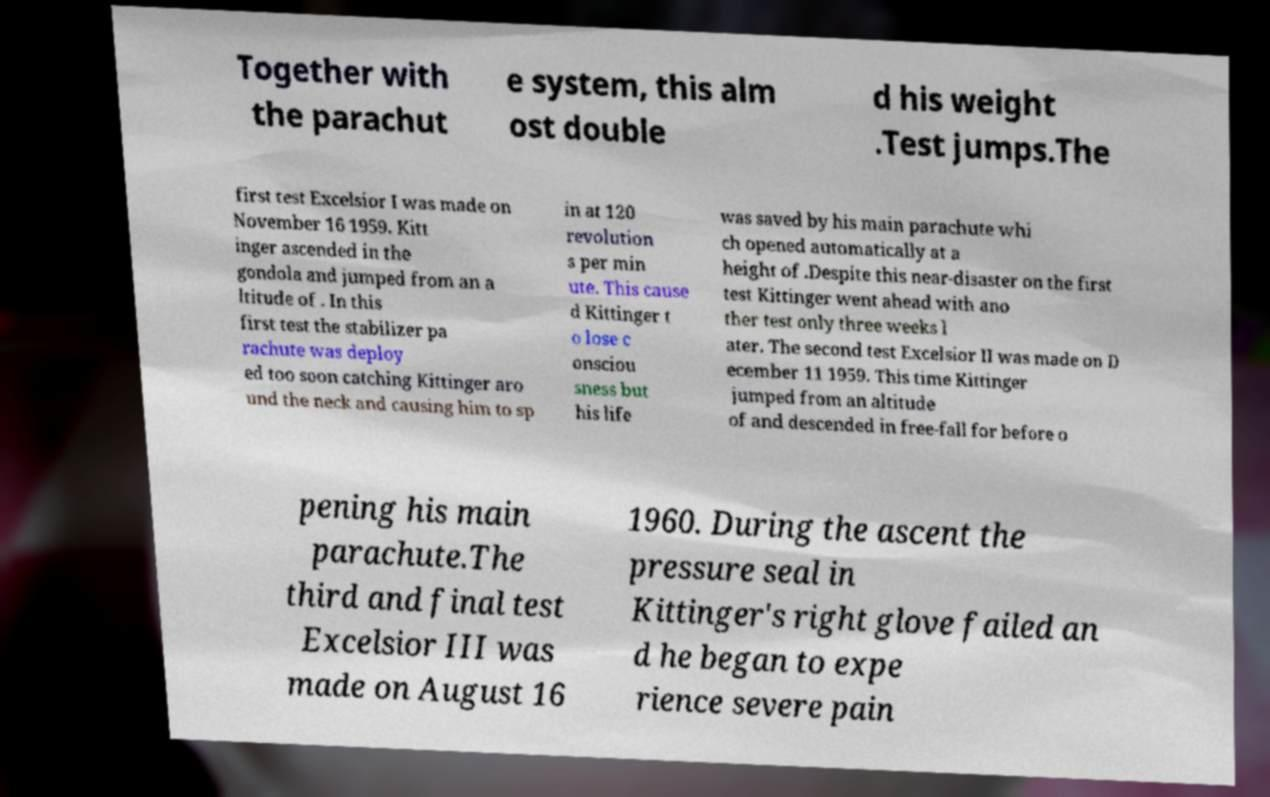Could you assist in decoding the text presented in this image and type it out clearly? Together with the parachut e system, this alm ost double d his weight .Test jumps.The first test Excelsior I was made on November 16 1959. Kitt inger ascended in the gondola and jumped from an a ltitude of . In this first test the stabilizer pa rachute was deploy ed too soon catching Kittinger aro und the neck and causing him to sp in at 120 revolution s per min ute. This cause d Kittinger t o lose c onsciou sness but his life was saved by his main parachute whi ch opened automatically at a height of .Despite this near-disaster on the first test Kittinger went ahead with ano ther test only three weeks l ater. The second test Excelsior II was made on D ecember 11 1959. This time Kittinger jumped from an altitude of and descended in free-fall for before o pening his main parachute.The third and final test Excelsior III was made on August 16 1960. During the ascent the pressure seal in Kittinger's right glove failed an d he began to expe rience severe pain 